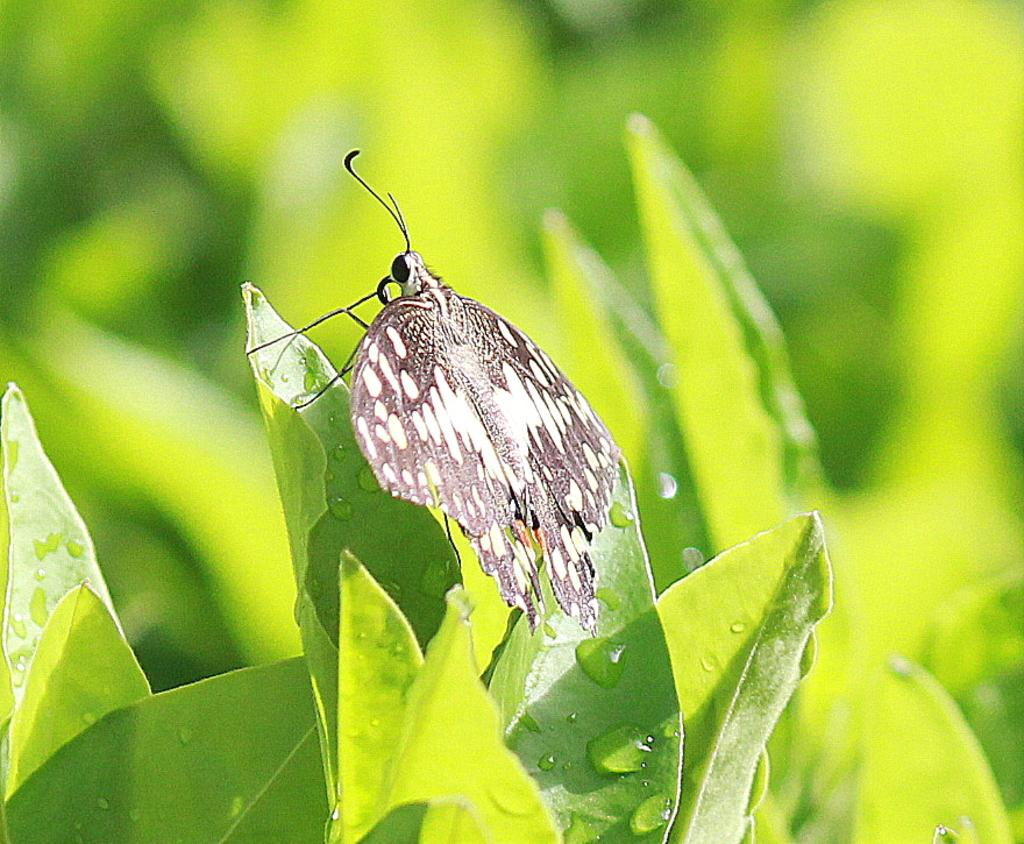What is the main subject of the image? There is a butterfly in the image. Where is the butterfly located? The butterfly is sitting on a leaf. What color are the leaves? The leaves are green. Can you describe the background of the image? The background of the image is blurred. What does the girl need to do to use the gun in the image? There is no girl or gun present in the image; it features a butterfly sitting on a leaf with green leaves in the background. 